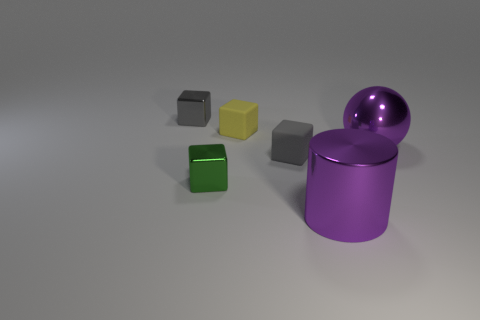Add 4 tiny balls. How many objects exist? 10 Subtract all cyan blocks. Subtract all brown balls. How many blocks are left? 4 Subtract all blocks. How many objects are left? 2 Subtract all tiny blocks. Subtract all small gray metallic things. How many objects are left? 1 Add 6 tiny green metal things. How many tiny green metal things are left? 7 Add 5 purple metallic spheres. How many purple metallic spheres exist? 6 Subtract 1 purple cylinders. How many objects are left? 5 